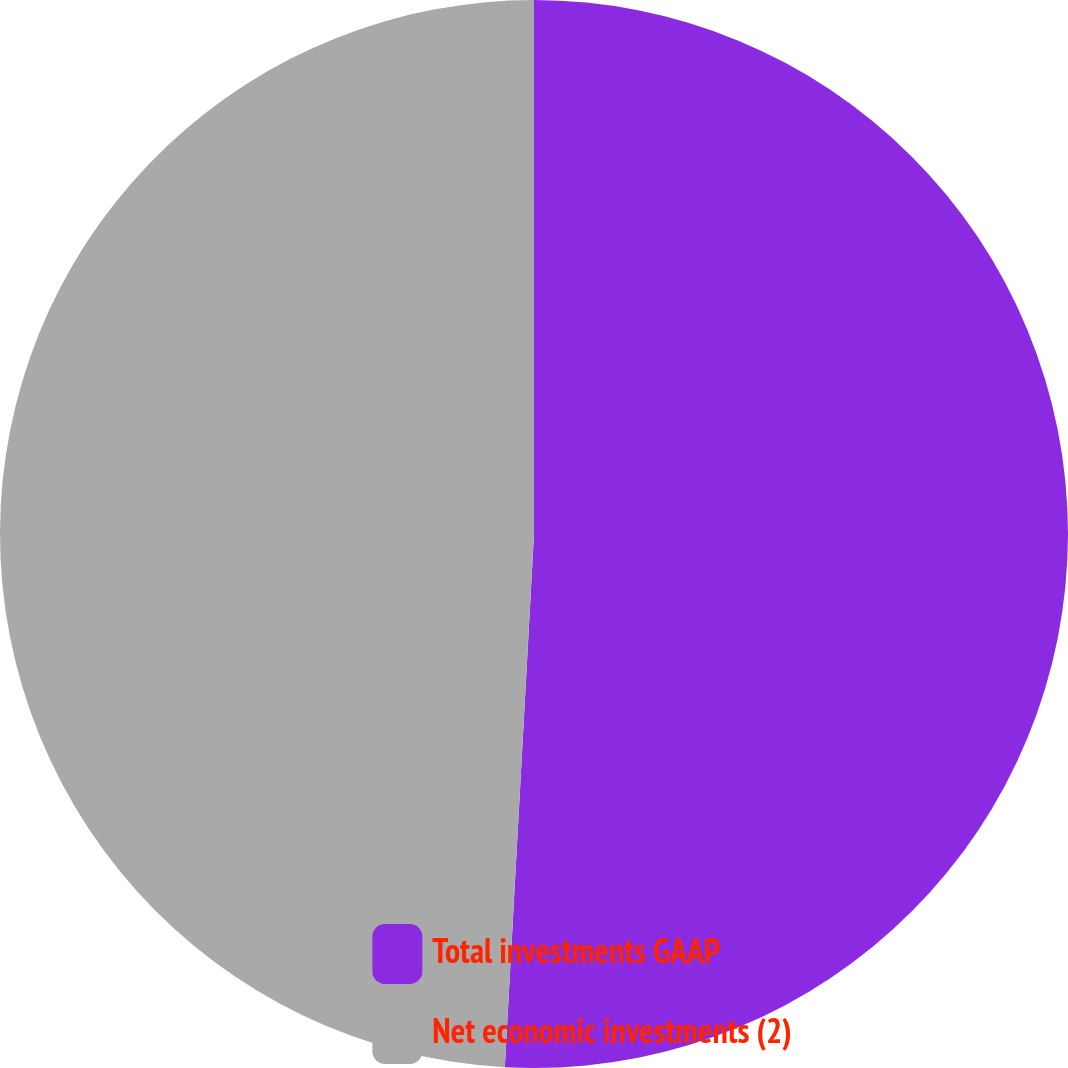Convert chart to OTSL. <chart><loc_0><loc_0><loc_500><loc_500><pie_chart><fcel>Total investments GAAP<fcel>Net economic investments (2)<nl><fcel>50.87%<fcel>49.13%<nl></chart> 